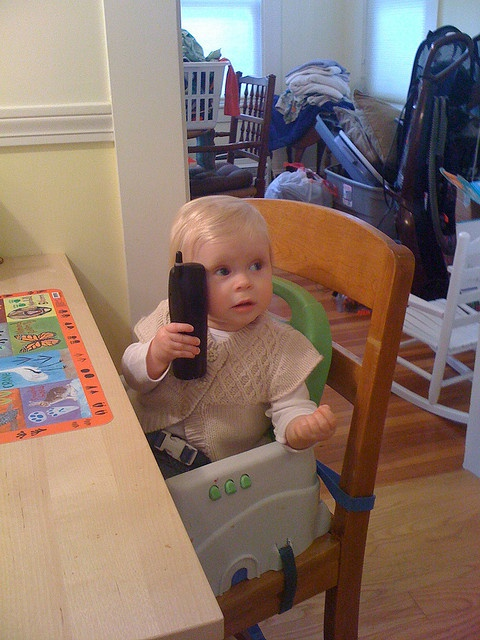Describe the objects in this image and their specific colors. I can see dining table in darkgray and tan tones, chair in darkgray, maroon, brown, olive, and black tones, people in darkgray, brown, and tan tones, chair in darkgray, gray, maroon, and black tones, and chair in darkgray, black, navy, gray, and purple tones in this image. 